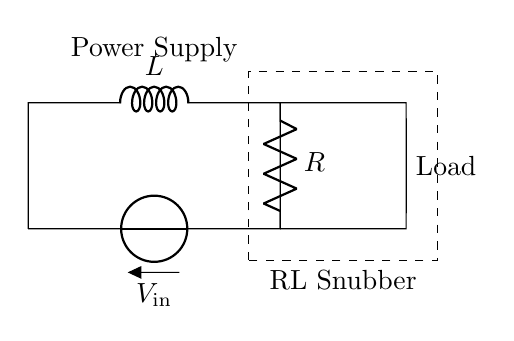What components are present in the circuit? The circuit contains an inductor (L), a resistor (R), and a voltage source (V). Each of these components can be identified in the diagram based on their symbols: the inductor is represented by a coiled line, the resistor by a zig-zag line, and the voltage source by a short and long line.
Answer: Inductor, Resistor, Voltage Source What is the function of the inductor in this circuit? The inductor primarily functions to store energy in the magnetic field when current flows through it and helps to smooth out voltage spikes, reducing electromagnetic interference. This is due to the property of inductance, which opposes changes in current.
Answer: Energy storage What is the load in this circuit? The load is present on the right side of the circuit diagram, and it is usually any device or component that consumes electrical power. In the diagram, it is indicated as "Load," indicating that it is the element that the power supply drives.
Answer: Load What does the dashed rectangle represent? The dashed rectangle encloses the RL snubber, indicating a specific section of the circuit where the resistor and inductor are implemented together to limit voltage transients and EMI (electromagnetic interference) effects. This area is particularly important for protecting sensitive components connected to the power supply.
Answer: RL Snubber How does the combination of the resistor and inductor reduce electromagnetic interference? The combination of the resistor and inductor creates a damping effect on voltage spikes; the resistor dissipates energy by converting it to heat, while the inductor suppresses sudden changes in current, leading to a more stable electrical environment. This reduces the probability of electromagnetic interference affecting the load.
Answer: Damping effect What is the voltage source labeled as in the circuit? It is labeled as V_in, indicating the input voltage supplied to the circuit that powers the components including the load, resistor, and inductor. This notation typically means the voltage that initiates current flow in the system.
Answer: V_in 